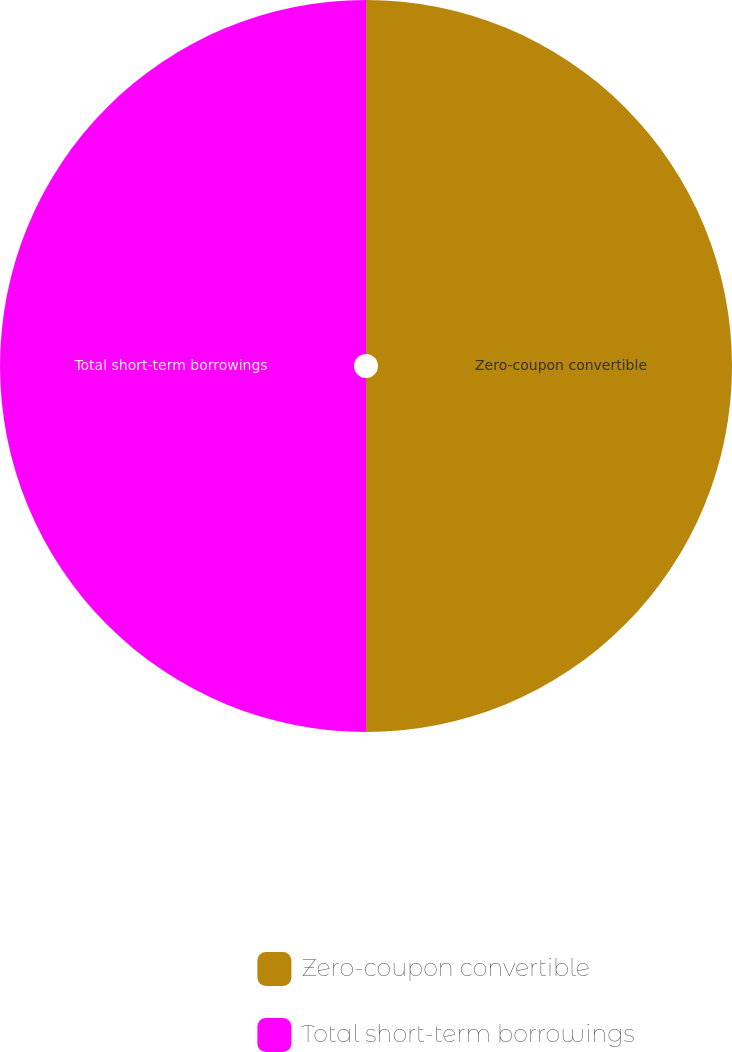Convert chart to OTSL. <chart><loc_0><loc_0><loc_500><loc_500><pie_chart><fcel>Zero-coupon convertible<fcel>Total short-term borrowings<nl><fcel>50.0%<fcel>50.0%<nl></chart> 